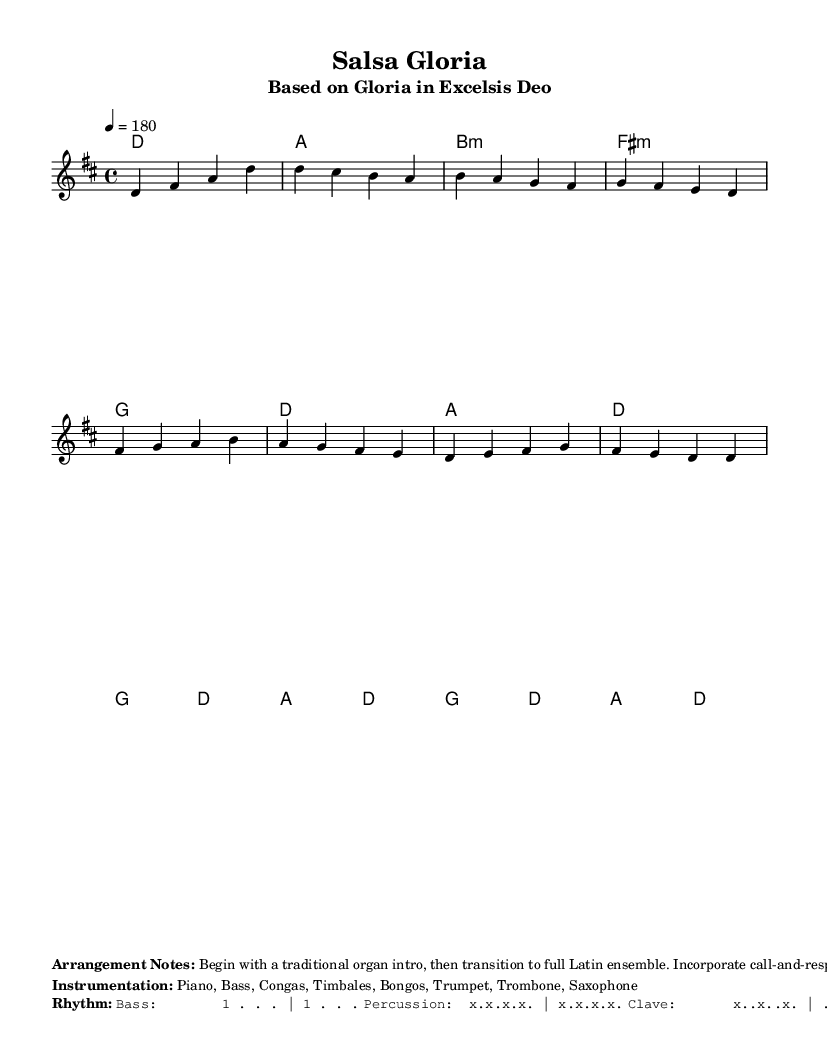What is the key signature of this music? The key signature is D major, which has two sharps: F# and C#. This can be identified in the global music settings.
Answer: D major What is the time signature of this piece? The time signature is 4/4, meaning there are four beats in each measure. This is indicated in the global settings and is a common time signature for dance music.
Answer: 4/4 What is the tempo of the piece? The tempo is 180 BPM (beats per minute), which suggests a lively pace suitable for dance. This is specified in the global settings.
Answer: 180 How many instruments are specified in the instrumentation? The instrumentation lists seven instruments: Piano, Bass, Congas, Timbales, Bongos, Trumpet, Trombone, Saxophone. This can be counted directly from the instrumentation section.
Answer: Seven Describe the beginning of the arrangement according to the notes. The arrangement notes indicate that it begins with a traditional organ intro, transitioning to a full Latin ensemble. This is explicitly stated in the arrangement notes section of the markup.
Answer: Traditional organ intro How does the piece end according to the arrangement notes? The piece ends with a gradual return to traditional hymn style, which is noted in the arrangement section as the concluding approach to the piece.
Answer: Gradual return to traditional hymn style 